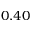<formula> <loc_0><loc_0><loc_500><loc_500>0 . 4 0</formula> 